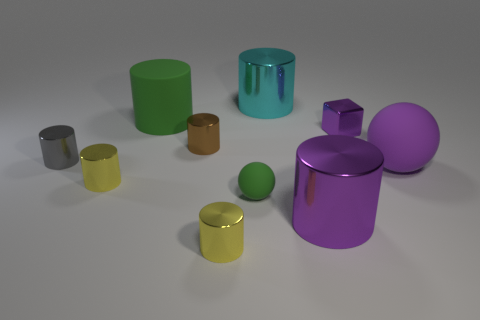Subtract all big cylinders. How many cylinders are left? 4 Subtract all cyan cylinders. How many cylinders are left? 6 Subtract all gray cylinders. Subtract all purple cubes. How many cylinders are left? 6 Subtract all cubes. How many objects are left? 9 Subtract all big cylinders. Subtract all small purple things. How many objects are left? 6 Add 2 small green spheres. How many small green spheres are left? 3 Add 1 purple shiny cylinders. How many purple shiny cylinders exist? 2 Subtract 0 blue balls. How many objects are left? 10 